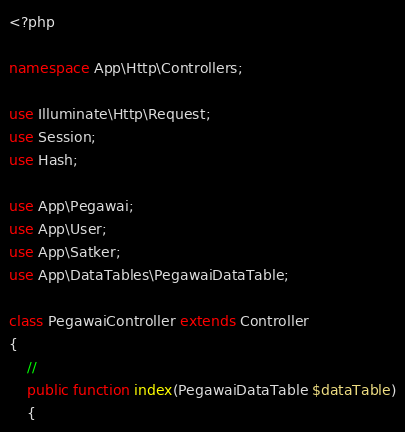Convert code to text. <code><loc_0><loc_0><loc_500><loc_500><_PHP_><?php

namespace App\Http\Controllers;

use Illuminate\Http\Request;
use Session;
use Hash;

use App\Pegawai;
use App\User;
use App\Satker;
use App\DataTables\PegawaiDataTable;

class PegawaiController extends Controller
{
    //
    public function index(PegawaiDataTable $dataTable)
    {</code> 